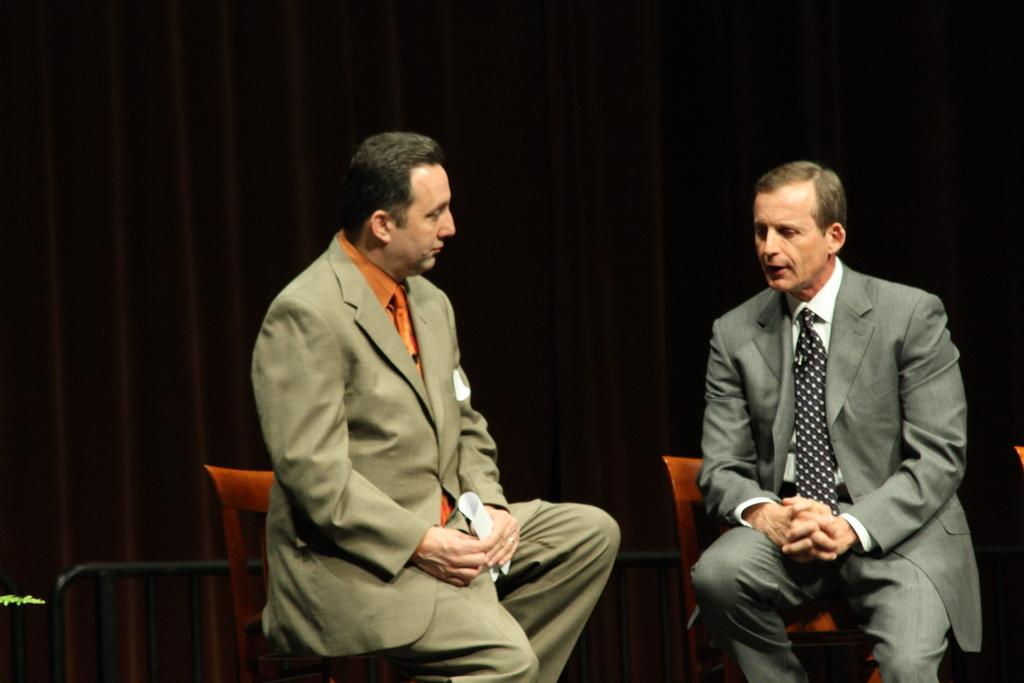How many people are in the image? There are two men in the image. What are the men doing in the image? The men are sitting on chairs. What type of clothing are the men wearing? Both men are wearing blazers, trousers, and ties. What can be seen in the background of the image? There is a curtain in the background of the image. Can you see a cup of coffee on the table in front of the men? There is no table or cup of coffee visible in the image. What type of knot is tied in the ties the men are wearing? The provided facts do not specify the type of knot in the ties, and there is no need to make assumptions about the image. 